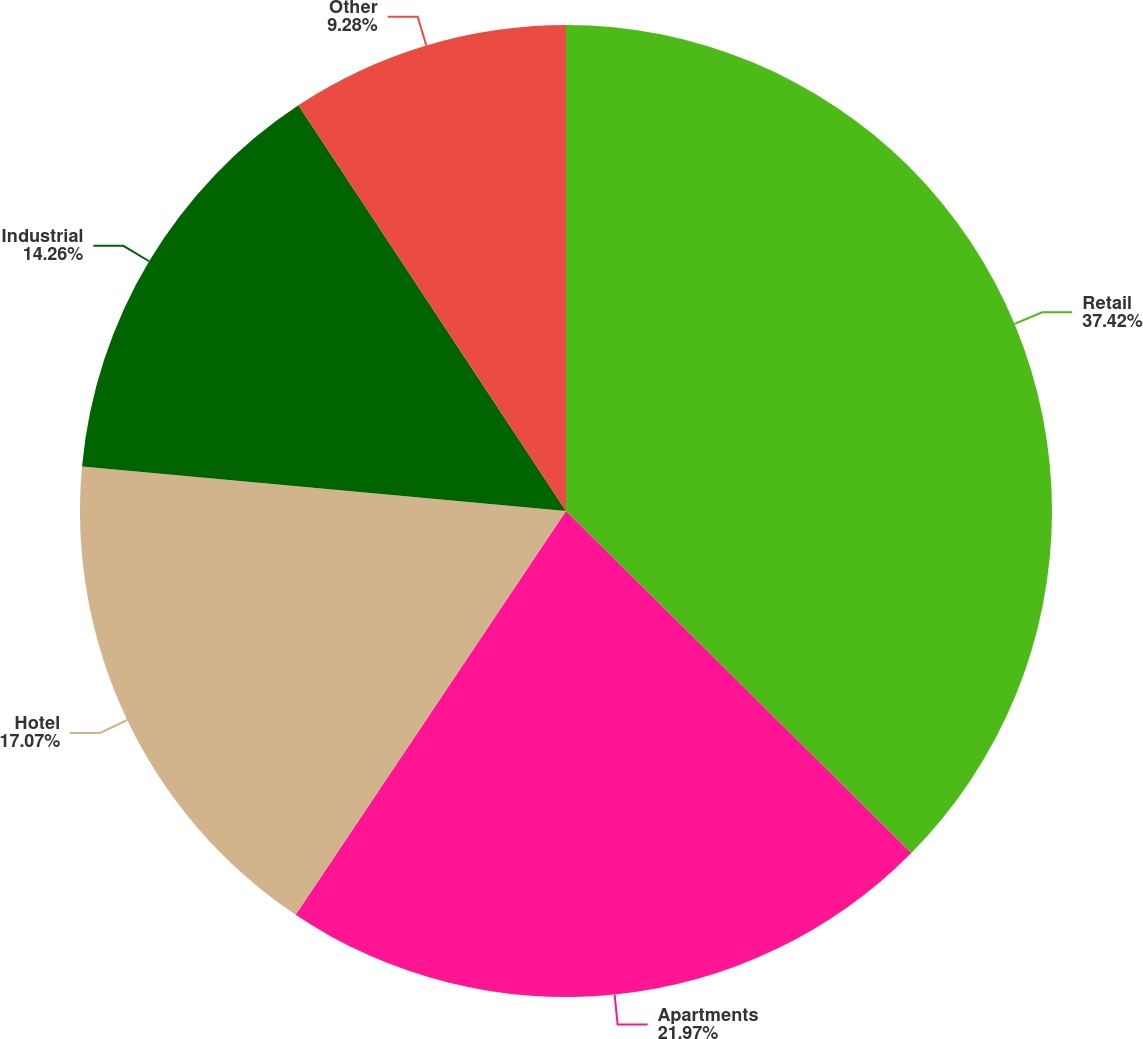Convert chart. <chart><loc_0><loc_0><loc_500><loc_500><pie_chart><fcel>Retail<fcel>Apartments<fcel>Hotel<fcel>Industrial<fcel>Other<nl><fcel>37.42%<fcel>21.97%<fcel>17.07%<fcel>14.26%<fcel>9.28%<nl></chart> 